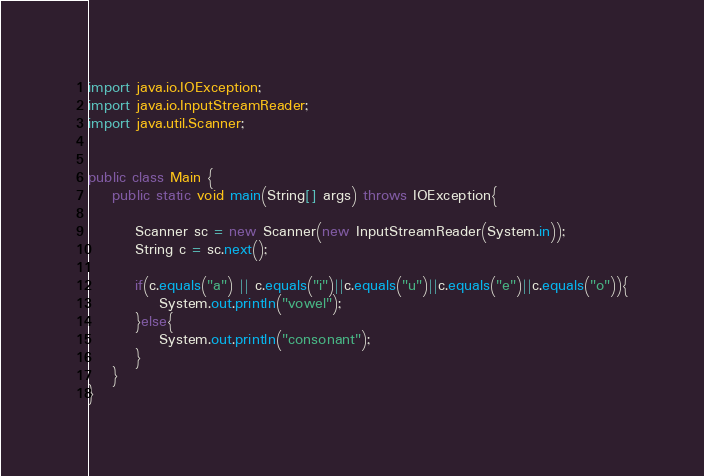<code> <loc_0><loc_0><loc_500><loc_500><_Java_>import java.io.IOException;
import java.io.InputStreamReader;
import java.util.Scanner;


public class Main {
	public static void main(String[] args) throws IOException{

		Scanner sc = new Scanner(new InputStreamReader(System.in));
		String c = sc.next();

		if(c.equals("a") || c.equals("i")||c.equals("u")||c.equals("e")||c.equals("o")){
			System.out.println("vowel");
	    }else{
	    	System.out.println("consonant");
	    }
	}
}
</code> 